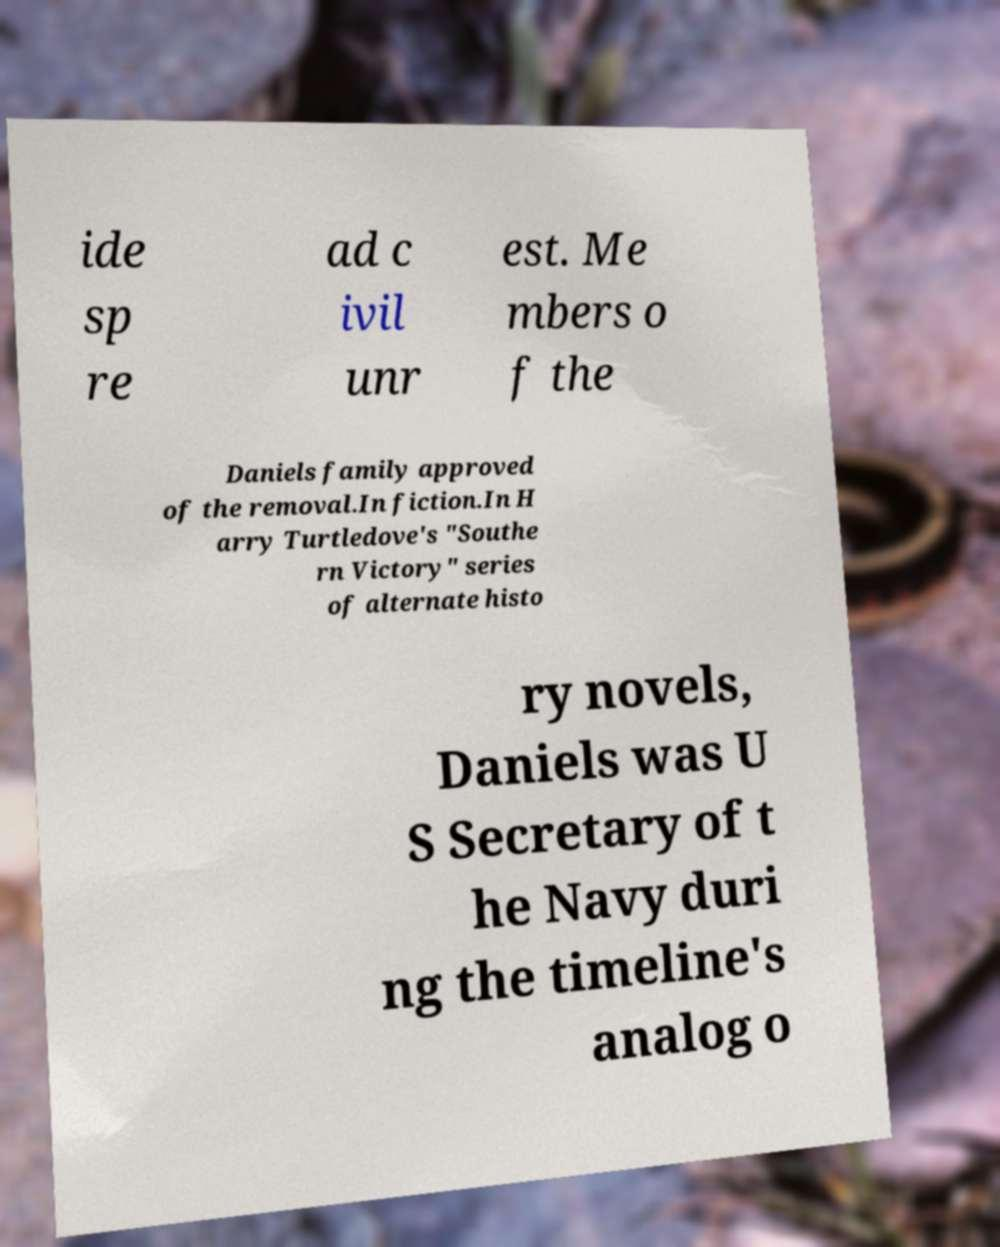Could you extract and type out the text from this image? ide sp re ad c ivil unr est. Me mbers o f the Daniels family approved of the removal.In fiction.In H arry Turtledove's "Southe rn Victory" series of alternate histo ry novels, Daniels was U S Secretary of t he Navy duri ng the timeline's analog o 